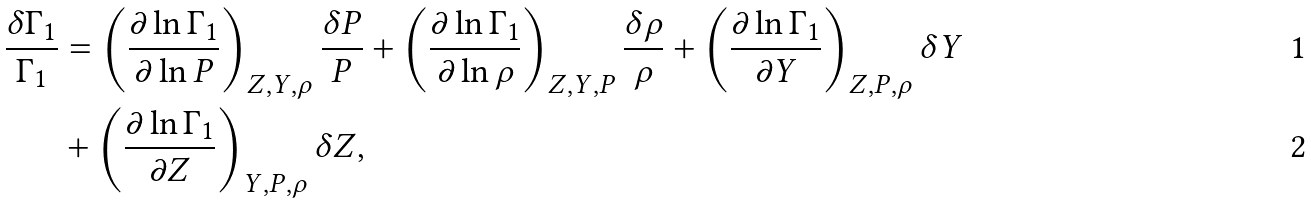<formula> <loc_0><loc_0><loc_500><loc_500>\frac { \delta \Gamma _ { 1 } } { \Gamma _ { 1 } } & = \left ( \frac { \partial \ln \Gamma _ { 1 } } { \partial \ln P } \right ) _ { Z , Y , \rho } \frac { \delta P } { P } + \left ( \frac { \partial \ln \Gamma _ { 1 } } { \partial \ln \rho } \right ) _ { Z , Y , P } \frac { \delta \rho } { \rho } + \left ( \frac { \partial \ln \Gamma _ { 1 } } { \partial Y } \right ) _ { Z , P , \rho } \delta Y \\ & + \left ( \frac { \partial \ln \Gamma _ { 1 } } { \partial Z } \right ) _ { Y , P , \rho } \delta Z ,</formula> 